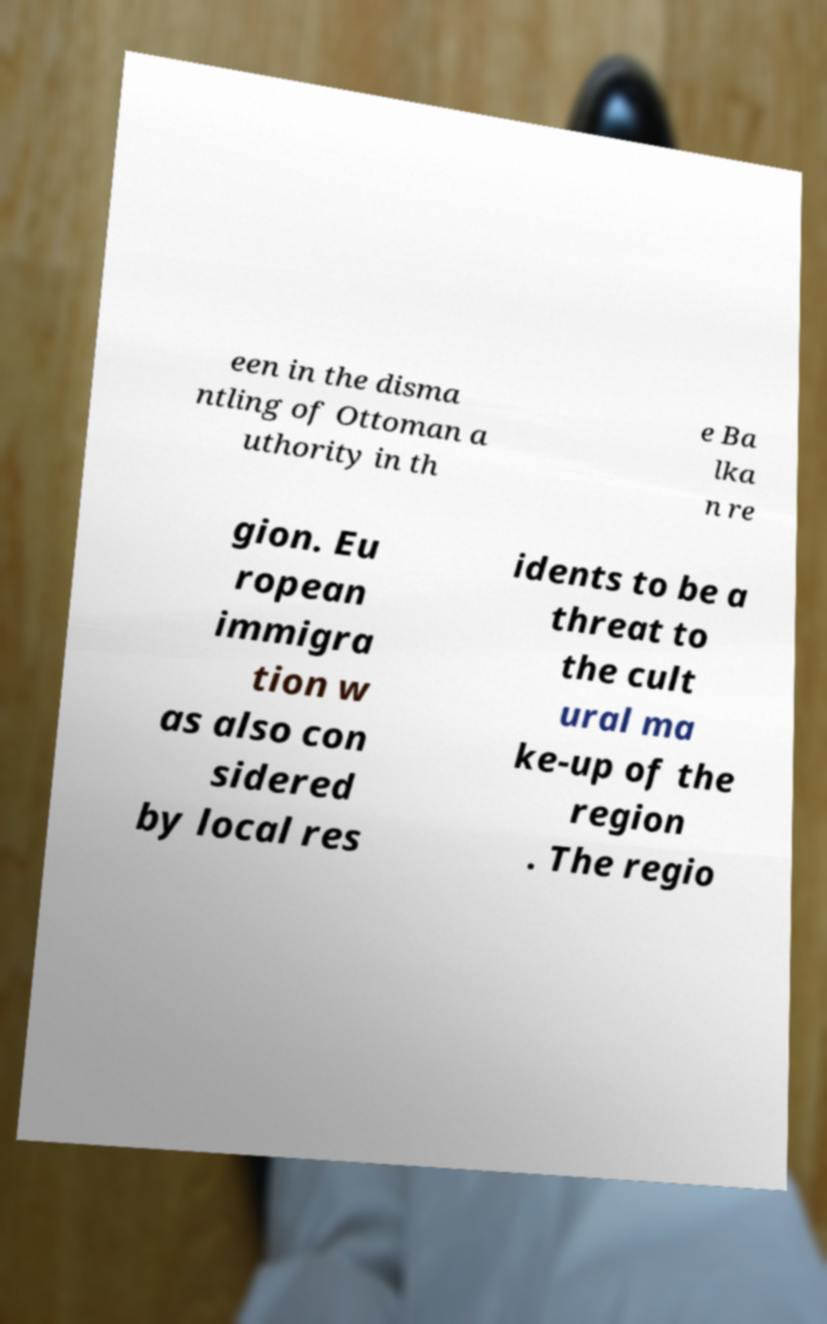Please read and relay the text visible in this image. What does it say? een in the disma ntling of Ottoman a uthority in th e Ba lka n re gion. Eu ropean immigra tion w as also con sidered by local res idents to be a threat to the cult ural ma ke-up of the region . The regio 